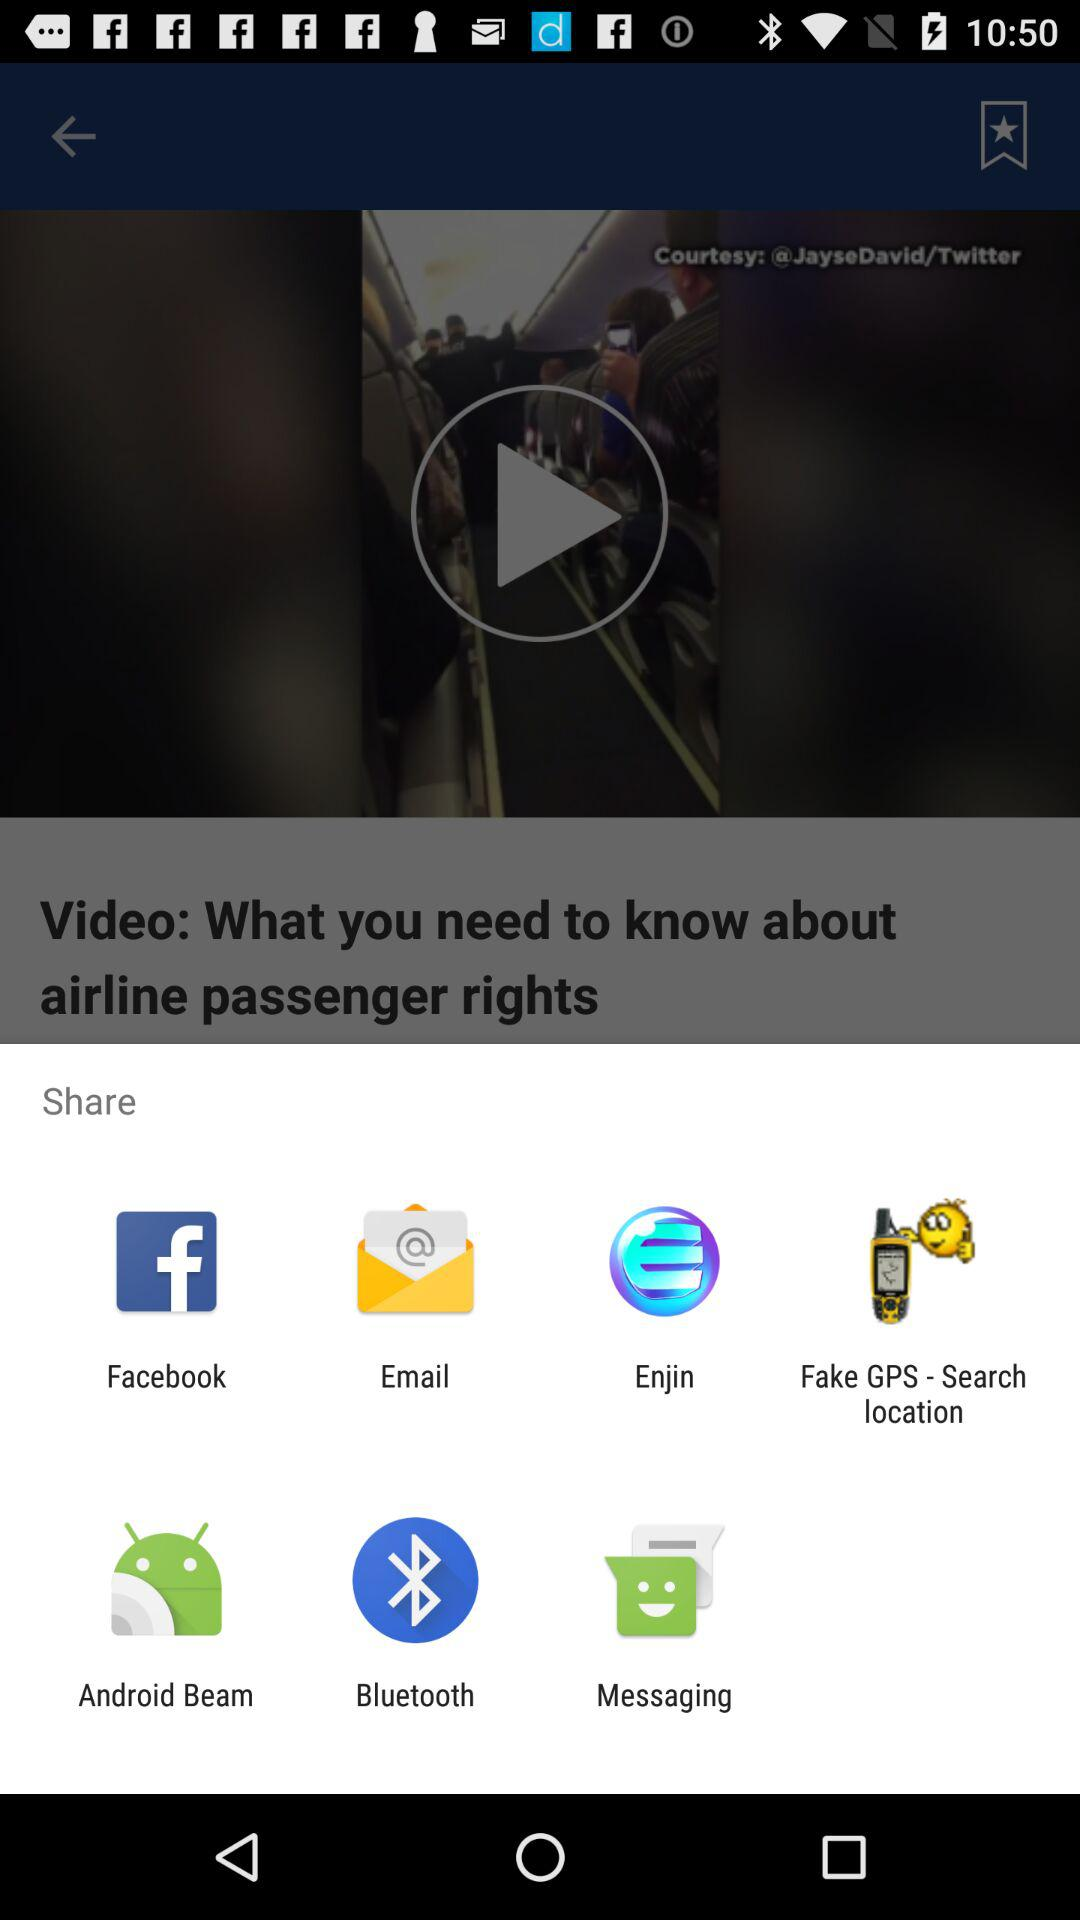What are the options to share? The options are "Facebook", "Email", "Enjin", "Fake GPS - Search location", "Android Beam", "Bluetooth" and "Messaging". 